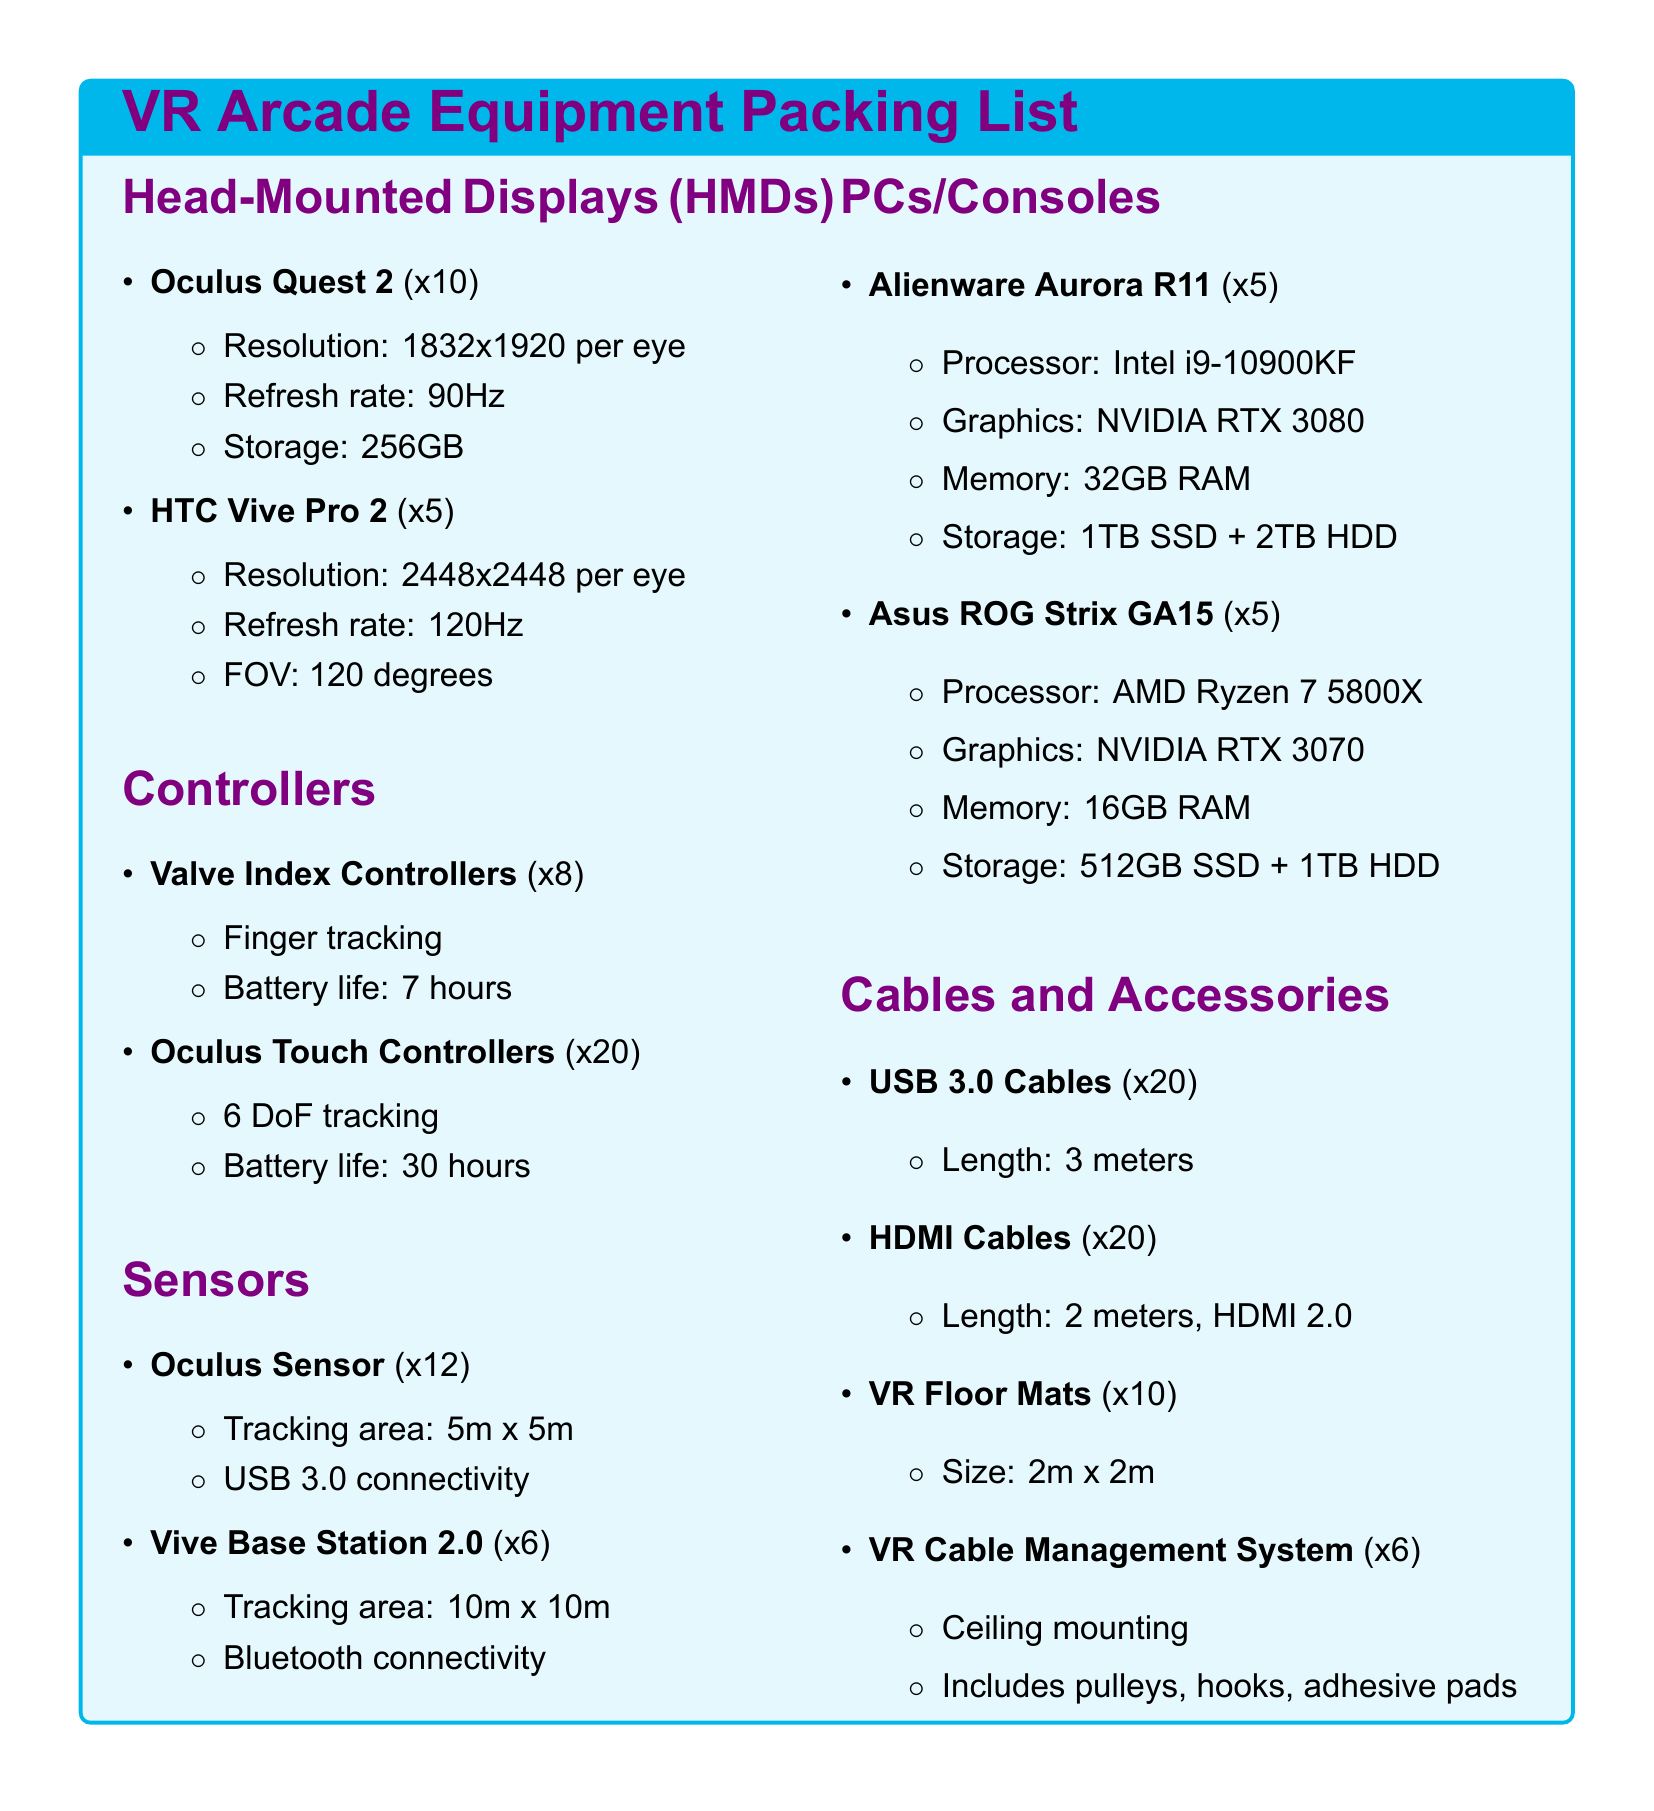What is the resolution of the Oculus Quest 2? The resolution is specified in the document as 1832x1920 per eye.
Answer: 1832x1920 per eye How many Valve Index Controllers are listed? The document states that there are 8 Valve Index Controllers.
Answer: 8 What is the refresh rate of the HTC Vive Pro 2? The refresh rate is mentioned as 120Hz in the equipment list.
Answer: 120Hz What is the tracking area of the Oculus Sensor? The tracking area is specified as 5m x 5m in the document.
Answer: 5m x 5m How many PCs are of the Alienware Aurora R11 model? There are 5 Alienware Aurora R11 PCs listed in the inventory.
Answer: 5 What storage does the Asus ROG Strix GA15 have? The storage for the Asus ROG Strix GA15 is 512GB SSD + 1TB HDD, according to the specifications.
Answer: 512GB SSD + 1TB HDD What is the battery life of the Oculus Touch Controllers? The battery life is specified in the document as 30 hours.
Answer: 30 hours How many VR Cable Management Systems are included? The document lists a total of 6 VR Cable Management Systems.
Answer: 6 What is the size of each VR Floor Mat? The size is noted as 2m x 2m in the packing list.
Answer: 2m x 2m 